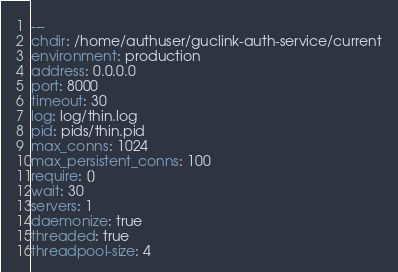Convert code to text. <code><loc_0><loc_0><loc_500><loc_500><_YAML_>---
chdir: /home/authuser/guclink-auth-service/current
environment: production
address: 0.0.0.0
port: 8000
timeout: 30
log: log/thin.log
pid: pids/thin.pid
max_conns: 1024
max_persistent_conns: 100
require: []
wait: 30
servers: 1
daemonize: true
threaded: true
threadpool-size: 4
</code> 